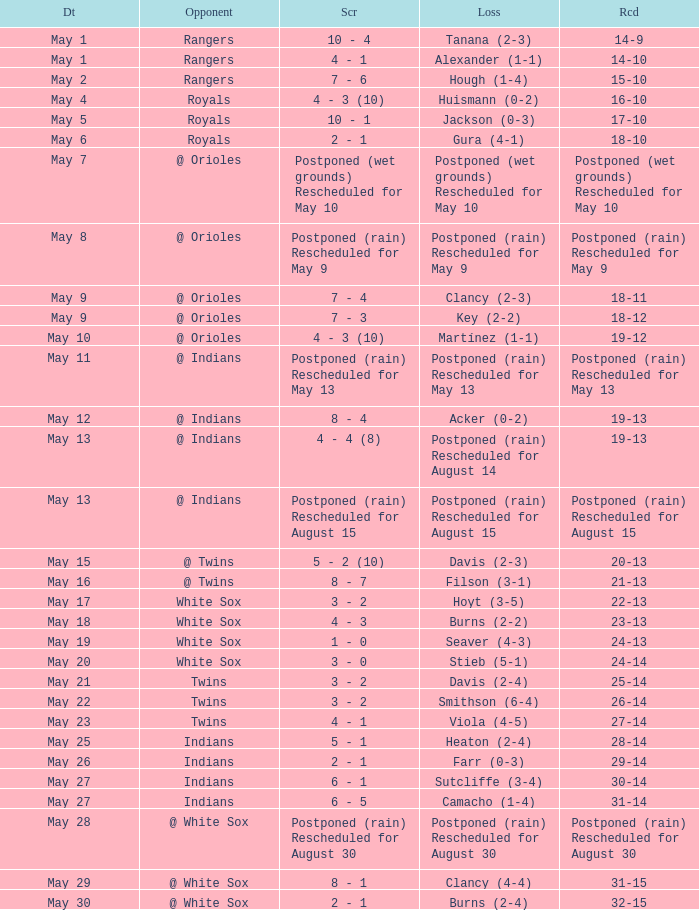What was the deficit of the match when the score was 21-13? Filson (3-1). 